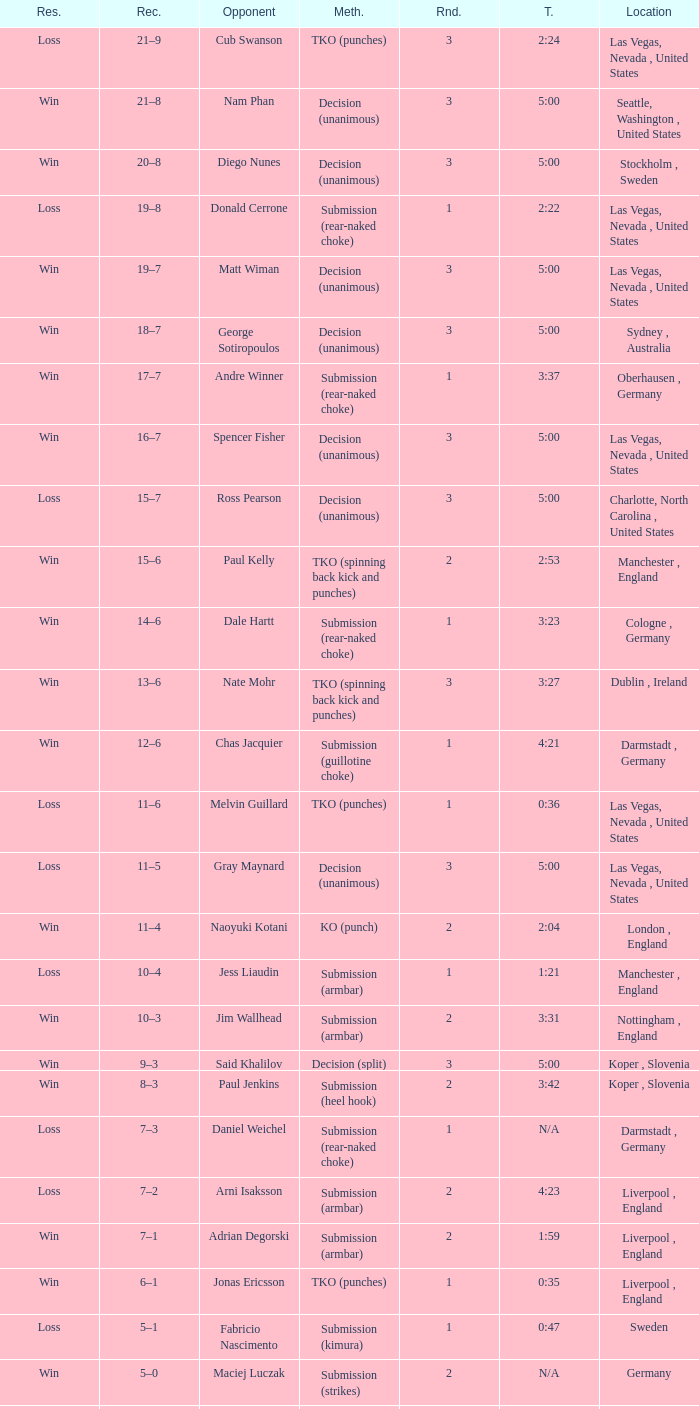Can you parse all the data within this table? {'header': ['Res.', 'Rec.', 'Opponent', 'Meth.', 'Rnd.', 'T.', 'Location'], 'rows': [['Loss', '21–9', 'Cub Swanson', 'TKO (punches)', '3', '2:24', 'Las Vegas, Nevada , United States'], ['Win', '21–8', 'Nam Phan', 'Decision (unanimous)', '3', '5:00', 'Seattle, Washington , United States'], ['Win', '20–8', 'Diego Nunes', 'Decision (unanimous)', '3', '5:00', 'Stockholm , Sweden'], ['Loss', '19–8', 'Donald Cerrone', 'Submission (rear-naked choke)', '1', '2:22', 'Las Vegas, Nevada , United States'], ['Win', '19–7', 'Matt Wiman', 'Decision (unanimous)', '3', '5:00', 'Las Vegas, Nevada , United States'], ['Win', '18–7', 'George Sotiropoulos', 'Decision (unanimous)', '3', '5:00', 'Sydney , Australia'], ['Win', '17–7', 'Andre Winner', 'Submission (rear-naked choke)', '1', '3:37', 'Oberhausen , Germany'], ['Win', '16–7', 'Spencer Fisher', 'Decision (unanimous)', '3', '5:00', 'Las Vegas, Nevada , United States'], ['Loss', '15–7', 'Ross Pearson', 'Decision (unanimous)', '3', '5:00', 'Charlotte, North Carolina , United States'], ['Win', '15–6', 'Paul Kelly', 'TKO (spinning back kick and punches)', '2', '2:53', 'Manchester , England'], ['Win', '14–6', 'Dale Hartt', 'Submission (rear-naked choke)', '1', '3:23', 'Cologne , Germany'], ['Win', '13–6', 'Nate Mohr', 'TKO (spinning back kick and punches)', '3', '3:27', 'Dublin , Ireland'], ['Win', '12–6', 'Chas Jacquier', 'Submission (guillotine choke)', '1', '4:21', 'Darmstadt , Germany'], ['Loss', '11–6', 'Melvin Guillard', 'TKO (punches)', '1', '0:36', 'Las Vegas, Nevada , United States'], ['Loss', '11–5', 'Gray Maynard', 'Decision (unanimous)', '3', '5:00', 'Las Vegas, Nevada , United States'], ['Win', '11–4', 'Naoyuki Kotani', 'KO (punch)', '2', '2:04', 'London , England'], ['Loss', '10–4', 'Jess Liaudin', 'Submission (armbar)', '1', '1:21', 'Manchester , England'], ['Win', '10–3', 'Jim Wallhead', 'Submission (armbar)', '2', '3:31', 'Nottingham , England'], ['Win', '9–3', 'Said Khalilov', 'Decision (split)', '3', '5:00', 'Koper , Slovenia'], ['Win', '8–3', 'Paul Jenkins', 'Submission (heel hook)', '2', '3:42', 'Koper , Slovenia'], ['Loss', '7–3', 'Daniel Weichel', 'Submission (rear-naked choke)', '1', 'N/A', 'Darmstadt , Germany'], ['Loss', '7–2', 'Arni Isaksson', 'Submission (armbar)', '2', '4:23', 'Liverpool , England'], ['Win', '7–1', 'Adrian Degorski', 'Submission (armbar)', '2', '1:59', 'Liverpool , England'], ['Win', '6–1', 'Jonas Ericsson', 'TKO (punches)', '1', '0:35', 'Liverpool , England'], ['Loss', '5–1', 'Fabricio Nascimento', 'Submission (kimura)', '1', '0:47', 'Sweden'], ['Win', '5–0', 'Maciej Luczak', 'Submission (strikes)', '2', 'N/A', 'Germany'], ['Win', '4–0', 'Dylan van Kooten', 'Submission (choke)', '1', 'N/A', 'Düsseldorf , Germany'], ['Win', '3–0', 'Kenneth Rosfort-Nees', 'TKO (cut)', '1', '5:00', 'Stockholm , Sweden'], ['Win', '2–0', 'Mohamed Omar', 'Decision (unanimous)', '3', '5:00', 'Trier , Germany'], ['Win', '1–0', 'Kordian Szukala', 'Submission (strikes)', '1', '0:17', 'Lübbecke , Germany']]} What was the method of resolution for the fight against dale hartt? Submission (rear-naked choke). 